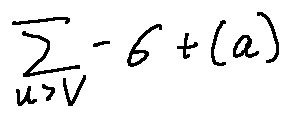Convert formula to latex. <formula><loc_0><loc_0><loc_500><loc_500>\sum \lim i t s _ { u > v } - \sigma + ( a )</formula> 